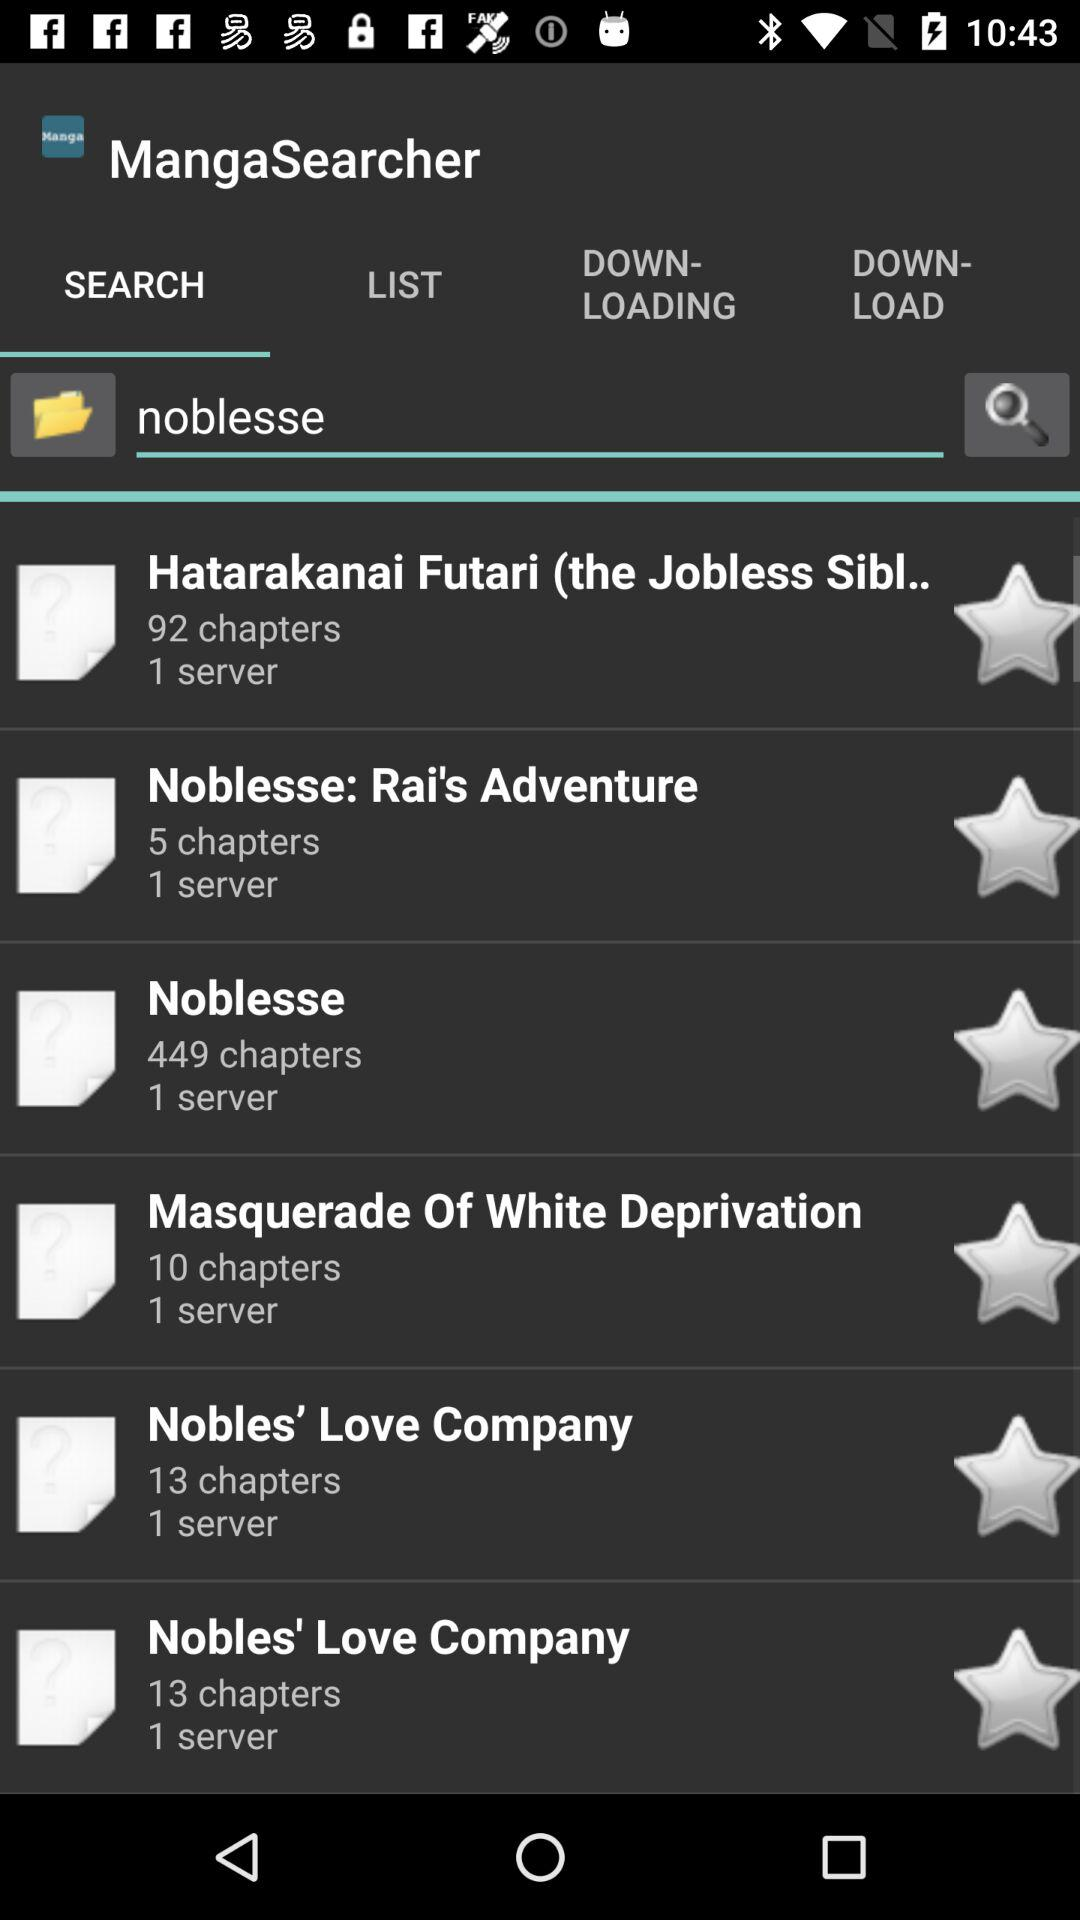Which tab is selected? The selected tab is "SEARCH". 